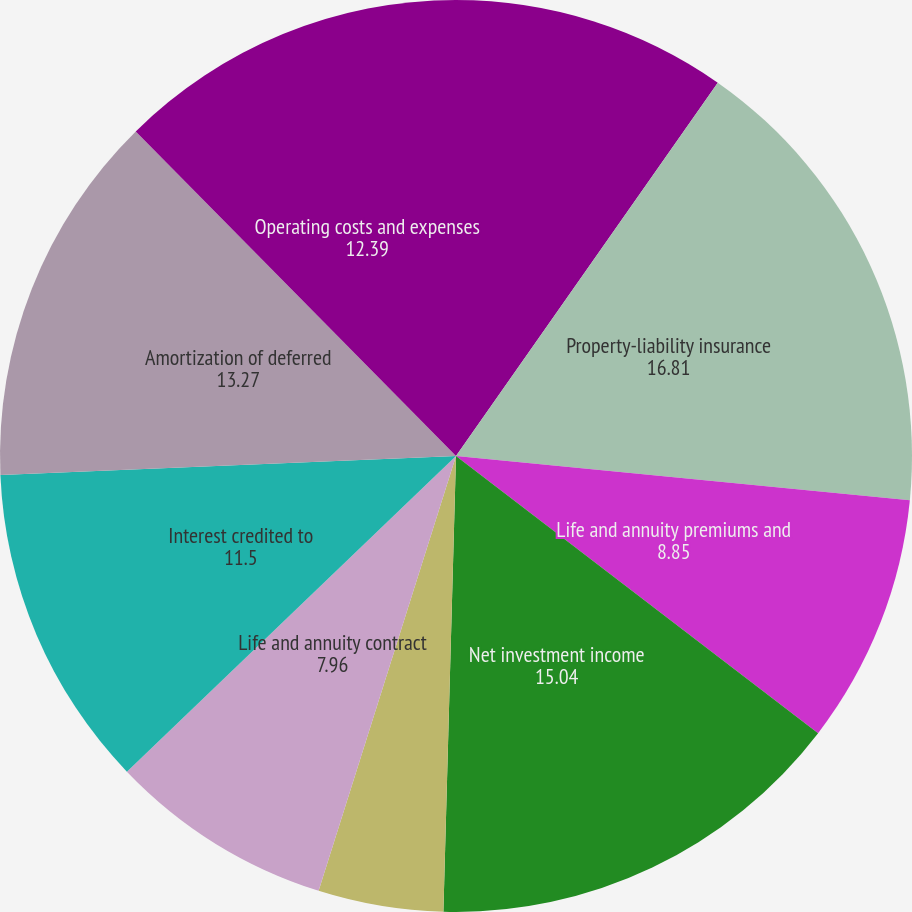Convert chart. <chart><loc_0><loc_0><loc_500><loc_500><pie_chart><fcel>( in millions except per share<fcel>Property-liability insurance<fcel>Life and annuity premiums and<fcel>Net investment income<fcel>Realized capital gains and<fcel>Life and annuity contract<fcel>Interest credited to<fcel>Amortization of deferred<fcel>Operating costs and expenses<nl><fcel>9.73%<fcel>16.81%<fcel>8.85%<fcel>15.04%<fcel>4.43%<fcel>7.96%<fcel>11.5%<fcel>13.27%<fcel>12.39%<nl></chart> 